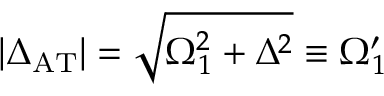<formula> <loc_0><loc_0><loc_500><loc_500>| \Delta _ { A T } | = \sqrt { \Omega _ { 1 } ^ { 2 } + \Delta ^ { 2 } } \equiv \Omega _ { 1 } ^ { \prime }</formula> 